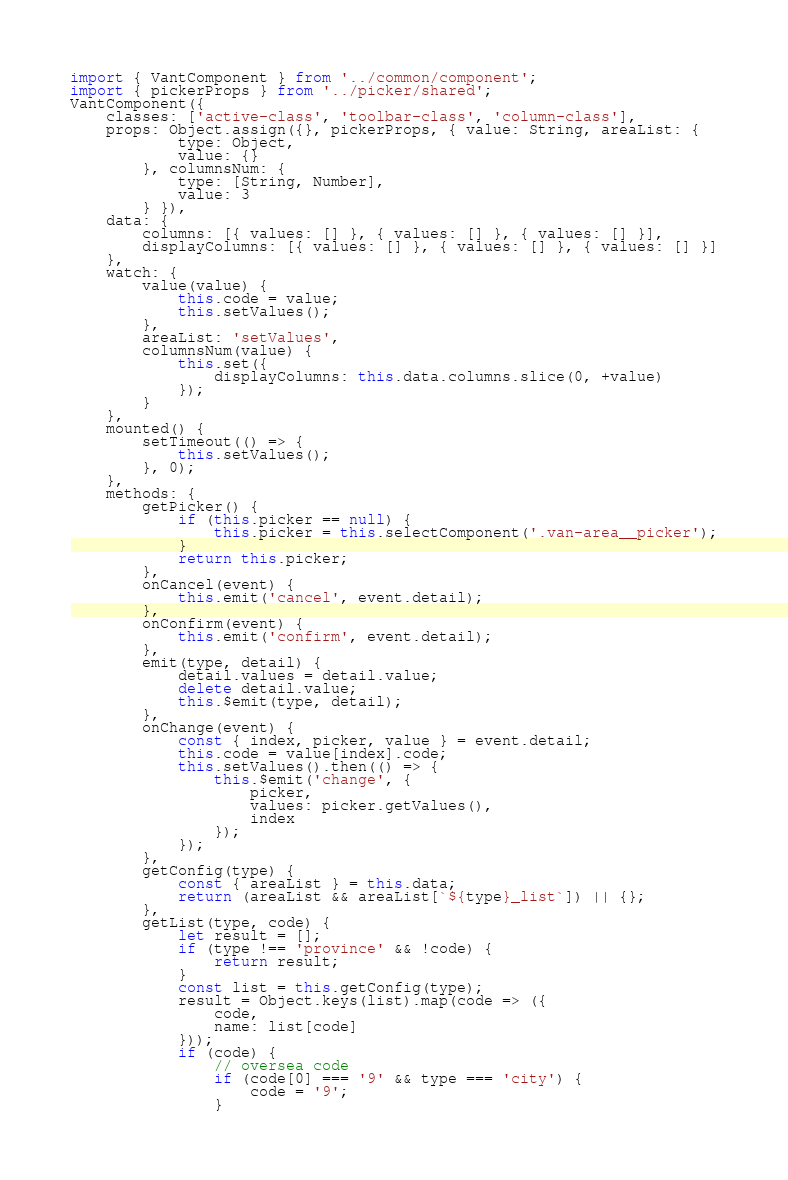Convert code to text. <code><loc_0><loc_0><loc_500><loc_500><_JavaScript_>import { VantComponent } from '../common/component';
import { pickerProps } from '../picker/shared';
VantComponent({
    classes: ['active-class', 'toolbar-class', 'column-class'],
    props: Object.assign({}, pickerProps, { value: String, areaList: {
            type: Object,
            value: {}
        }, columnsNum: {
            type: [String, Number],
            value: 3
        } }),
    data: {
        columns: [{ values: [] }, { values: [] }, { values: [] }],
        displayColumns: [{ values: [] }, { values: [] }, { values: [] }]
    },
    watch: {
        value(value) {
            this.code = value;
            this.setValues();
        },
        areaList: 'setValues',
        columnsNum(value) {
            this.set({
                displayColumns: this.data.columns.slice(0, +value)
            });
        }
    },
    mounted() {
        setTimeout(() => {
            this.setValues();
        }, 0);
    },
    methods: {
        getPicker() {
            if (this.picker == null) {
                this.picker = this.selectComponent('.van-area__picker');
            }
            return this.picker;
        },
        onCancel(event) {
            this.emit('cancel', event.detail);
        },
        onConfirm(event) {
            this.emit('confirm', event.detail);
        },
        emit(type, detail) {
            detail.values = detail.value;
            delete detail.value;
            this.$emit(type, detail);
        },
        onChange(event) {
            const { index, picker, value } = event.detail;
            this.code = value[index].code;
            this.setValues().then(() => {
                this.$emit('change', {
                    picker,
                    values: picker.getValues(),
                    index
                });
            });
        },
        getConfig(type) {
            const { areaList } = this.data;
            return (areaList && areaList[`${type}_list`]) || {};
        },
        getList(type, code) {
            let result = [];
            if (type !== 'province' && !code) {
                return result;
            }
            const list = this.getConfig(type);
            result = Object.keys(list).map(code => ({
                code,
                name: list[code]
            }));
            if (code) {
                // oversea code
                if (code[0] === '9' && type === 'city') {
                    code = '9';
                }</code> 